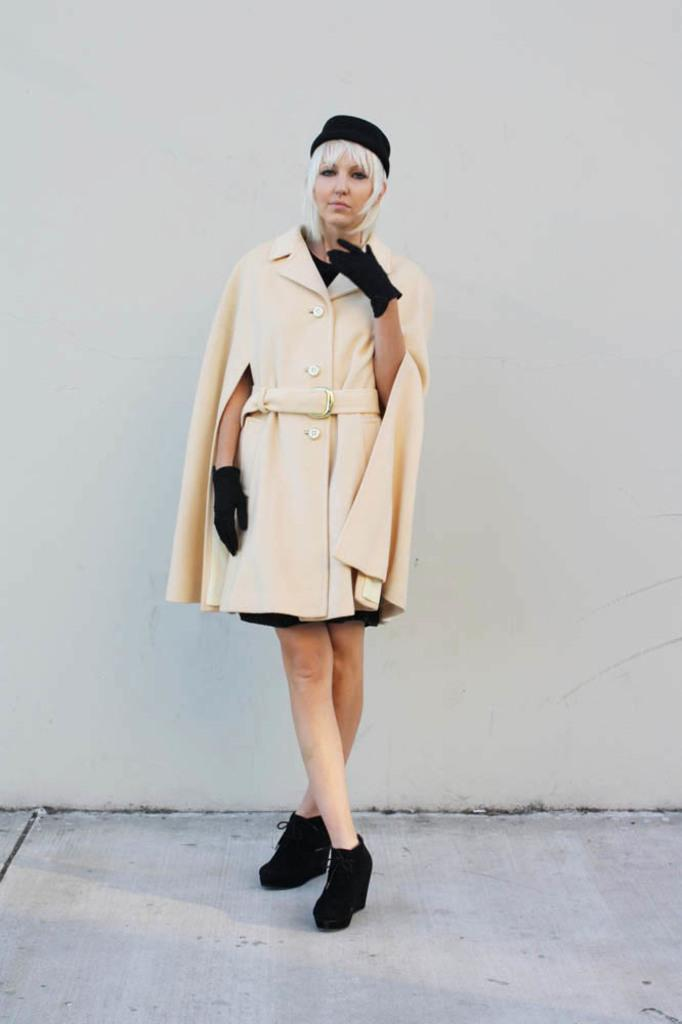Who is the main subject in the image? There is a lady in the center of the image. What is the lady wearing? The lady is wearing a jacket. What is the surface beneath the lady's feet in the image? There is a floor at the bottom of the image. What can be seen behind the lady in the image? There is a wall in the background of the image. What emotion is the beggar displaying in the image? There is no beggar present in the image, and therefore no emotion can be attributed to them. 